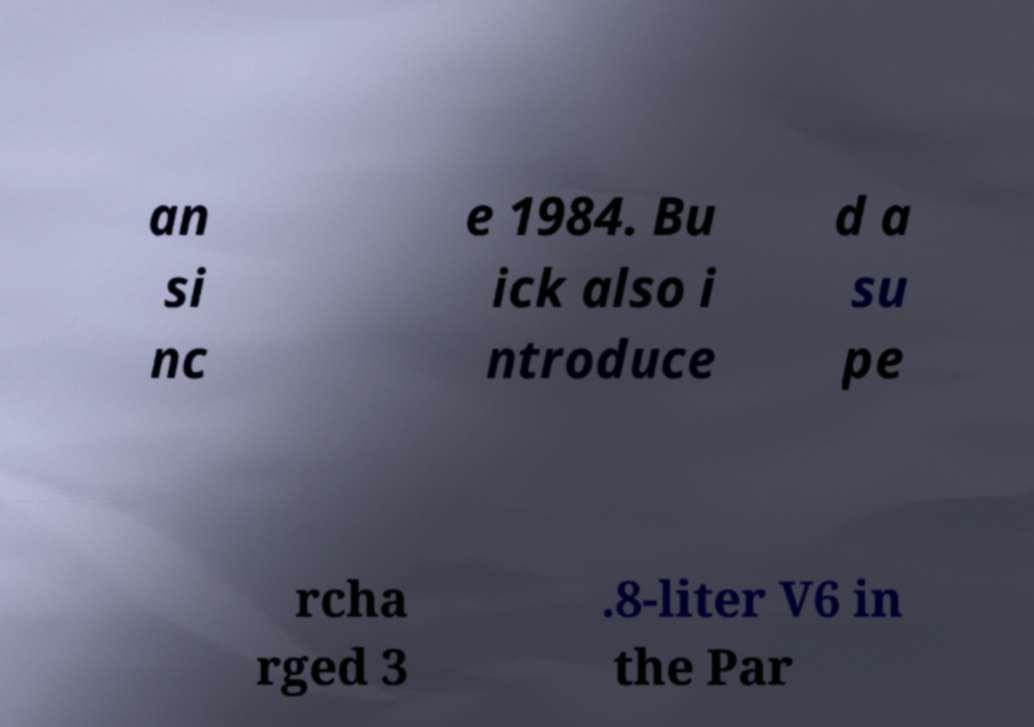Could you extract and type out the text from this image? an si nc e 1984. Bu ick also i ntroduce d a su pe rcha rged 3 .8-liter V6 in the Par 